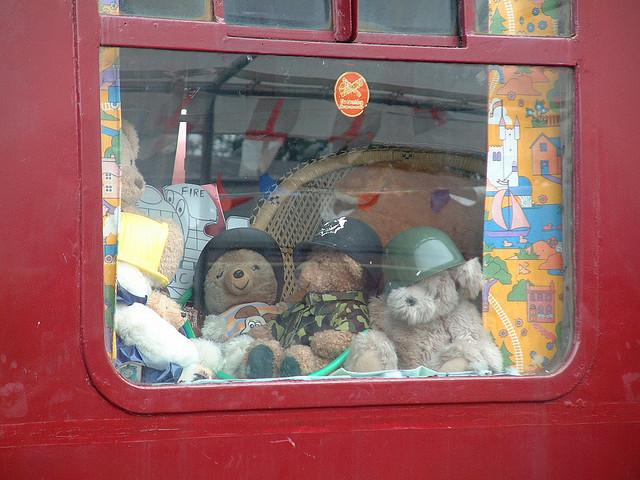What are the toys in the window called? Please explain your reasoning. teddy bears. There are many popular dolls but the one that imitates bears, or the teddy bear, is very easy to spot. 